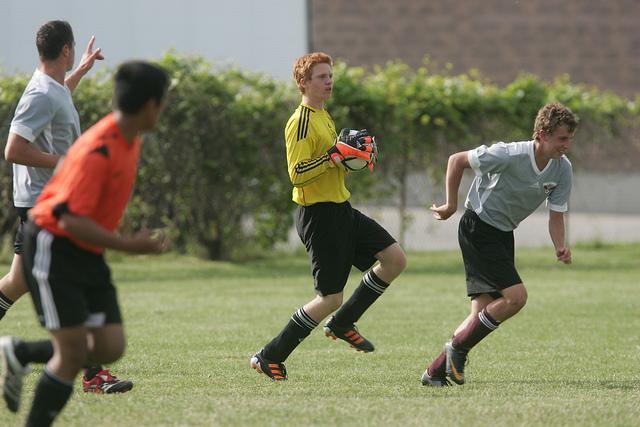How many people are in the picture?
Give a very brief answer. 4. 